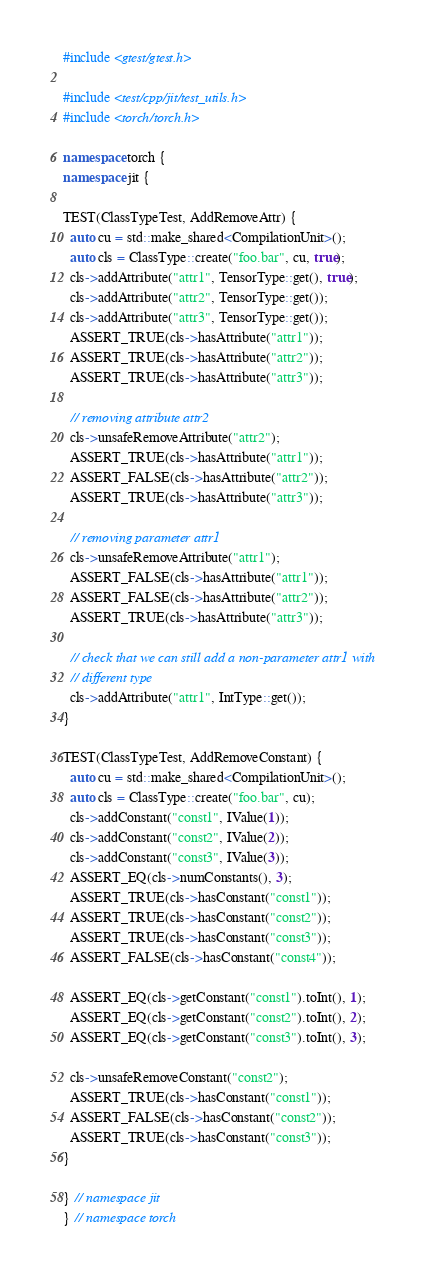Convert code to text. <code><loc_0><loc_0><loc_500><loc_500><_C++_>#include <gtest/gtest.h>

#include <test/cpp/jit/test_utils.h>
#include <torch/torch.h>

namespace torch {
namespace jit {

TEST(ClassTypeTest, AddRemoveAttr) {
  auto cu = std::make_shared<CompilationUnit>();
  auto cls = ClassType::create("foo.bar", cu, true);
  cls->addAttribute("attr1", TensorType::get(), true);
  cls->addAttribute("attr2", TensorType::get());
  cls->addAttribute("attr3", TensorType::get());
  ASSERT_TRUE(cls->hasAttribute("attr1"));
  ASSERT_TRUE(cls->hasAttribute("attr2"));
  ASSERT_TRUE(cls->hasAttribute("attr3"));

  // removing attribute attr2
  cls->unsafeRemoveAttribute("attr2");
  ASSERT_TRUE(cls->hasAttribute("attr1"));
  ASSERT_FALSE(cls->hasAttribute("attr2"));
  ASSERT_TRUE(cls->hasAttribute("attr3"));

  // removing parameter attr1
  cls->unsafeRemoveAttribute("attr1");
  ASSERT_FALSE(cls->hasAttribute("attr1"));
  ASSERT_FALSE(cls->hasAttribute("attr2"));
  ASSERT_TRUE(cls->hasAttribute("attr3"));

  // check that we can still add a non-parameter attr1 with
  // different type
  cls->addAttribute("attr1", IntType::get());
}

TEST(ClassTypeTest, AddRemoveConstant) {
  auto cu = std::make_shared<CompilationUnit>();
  auto cls = ClassType::create("foo.bar", cu);
  cls->addConstant("const1", IValue(1));
  cls->addConstant("const2", IValue(2));
  cls->addConstant("const3", IValue(3));
  ASSERT_EQ(cls->numConstants(), 3);
  ASSERT_TRUE(cls->hasConstant("const1"));
  ASSERT_TRUE(cls->hasConstant("const2"));
  ASSERT_TRUE(cls->hasConstant("const3"));
  ASSERT_FALSE(cls->hasConstant("const4"));

  ASSERT_EQ(cls->getConstant("const1").toInt(), 1);
  ASSERT_EQ(cls->getConstant("const2").toInt(), 2);
  ASSERT_EQ(cls->getConstant("const3").toInt(), 3);

  cls->unsafeRemoveConstant("const2");
  ASSERT_TRUE(cls->hasConstant("const1"));
  ASSERT_FALSE(cls->hasConstant("const2"));
  ASSERT_TRUE(cls->hasConstant("const3"));
}

} // namespace jit
} // namespace torch
</code> 